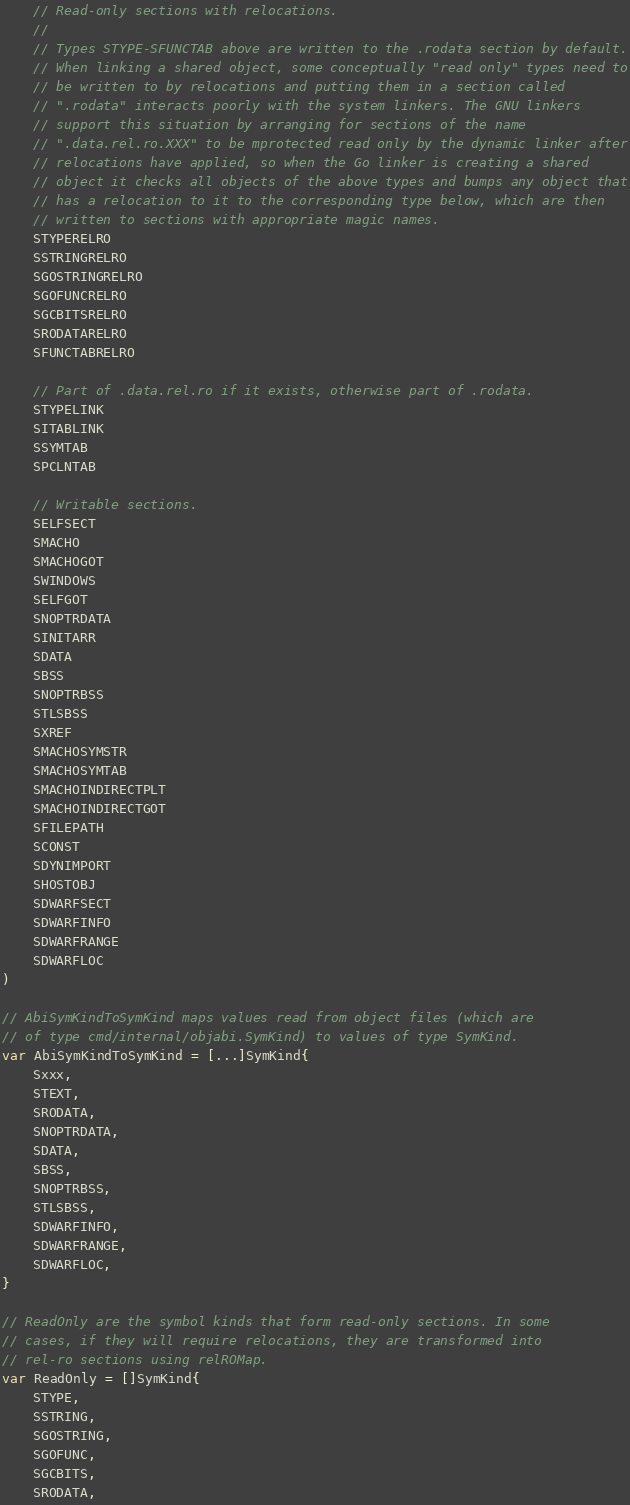Convert code to text. <code><loc_0><loc_0><loc_500><loc_500><_Go_>
	// Read-only sections with relocations.
	//
	// Types STYPE-SFUNCTAB above are written to the .rodata section by default.
	// When linking a shared object, some conceptually "read only" types need to
	// be written to by relocations and putting them in a section called
	// ".rodata" interacts poorly with the system linkers. The GNU linkers
	// support this situation by arranging for sections of the name
	// ".data.rel.ro.XXX" to be mprotected read only by the dynamic linker after
	// relocations have applied, so when the Go linker is creating a shared
	// object it checks all objects of the above types and bumps any object that
	// has a relocation to it to the corresponding type below, which are then
	// written to sections with appropriate magic names.
	STYPERELRO
	SSTRINGRELRO
	SGOSTRINGRELRO
	SGOFUNCRELRO
	SGCBITSRELRO
	SRODATARELRO
	SFUNCTABRELRO

	// Part of .data.rel.ro if it exists, otherwise part of .rodata.
	STYPELINK
	SITABLINK
	SSYMTAB
	SPCLNTAB

	// Writable sections.
	SELFSECT
	SMACHO
	SMACHOGOT
	SWINDOWS
	SELFGOT
	SNOPTRDATA
	SINITARR
	SDATA
	SBSS
	SNOPTRBSS
	STLSBSS
	SXREF
	SMACHOSYMSTR
	SMACHOSYMTAB
	SMACHOINDIRECTPLT
	SMACHOINDIRECTGOT
	SFILEPATH
	SCONST
	SDYNIMPORT
	SHOSTOBJ
	SDWARFSECT
	SDWARFINFO
	SDWARFRANGE
	SDWARFLOC
)

// AbiSymKindToSymKind maps values read from object files (which are
// of type cmd/internal/objabi.SymKind) to values of type SymKind.
var AbiSymKindToSymKind = [...]SymKind{
	Sxxx,
	STEXT,
	SRODATA,
	SNOPTRDATA,
	SDATA,
	SBSS,
	SNOPTRBSS,
	STLSBSS,
	SDWARFINFO,
	SDWARFRANGE,
	SDWARFLOC,
}

// ReadOnly are the symbol kinds that form read-only sections. In some
// cases, if they will require relocations, they are transformed into
// rel-ro sections using relROMap.
var ReadOnly = []SymKind{
	STYPE,
	SSTRING,
	SGOSTRING,
	SGOFUNC,
	SGCBITS,
	SRODATA,</code> 